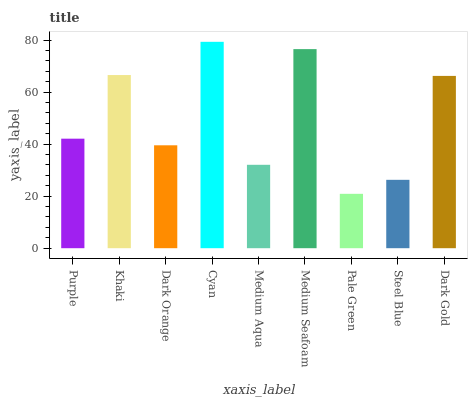Is Pale Green the minimum?
Answer yes or no. Yes. Is Cyan the maximum?
Answer yes or no. Yes. Is Khaki the minimum?
Answer yes or no. No. Is Khaki the maximum?
Answer yes or no. No. Is Khaki greater than Purple?
Answer yes or no. Yes. Is Purple less than Khaki?
Answer yes or no. Yes. Is Purple greater than Khaki?
Answer yes or no. No. Is Khaki less than Purple?
Answer yes or no. No. Is Purple the high median?
Answer yes or no. Yes. Is Purple the low median?
Answer yes or no. Yes. Is Dark Gold the high median?
Answer yes or no. No. Is Medium Aqua the low median?
Answer yes or no. No. 